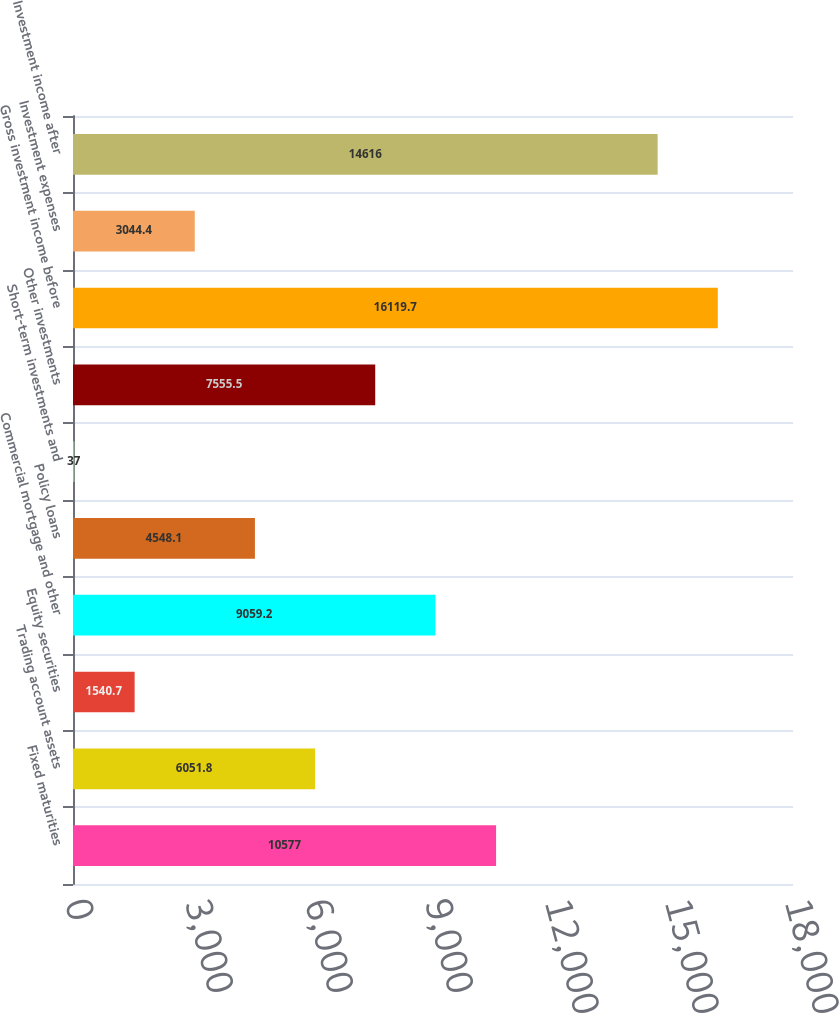Convert chart to OTSL. <chart><loc_0><loc_0><loc_500><loc_500><bar_chart><fcel>Fixed maturities<fcel>Trading account assets<fcel>Equity securities<fcel>Commercial mortgage and other<fcel>Policy loans<fcel>Short-term investments and<fcel>Other investments<fcel>Gross investment income before<fcel>Investment expenses<fcel>Investment income after<nl><fcel>10577<fcel>6051.8<fcel>1540.7<fcel>9059.2<fcel>4548.1<fcel>37<fcel>7555.5<fcel>16119.7<fcel>3044.4<fcel>14616<nl></chart> 